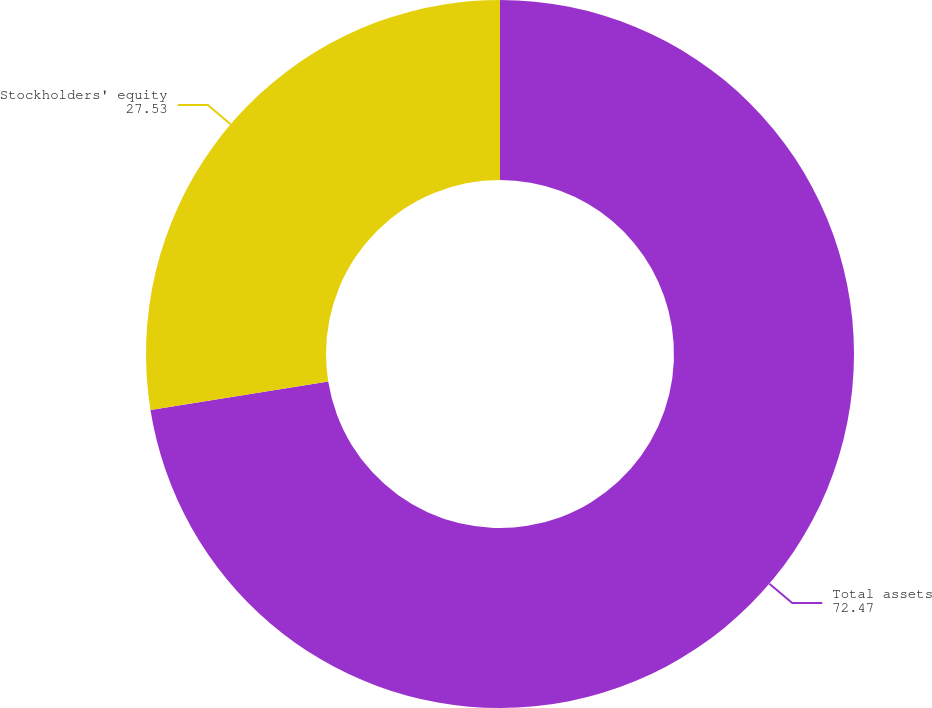<chart> <loc_0><loc_0><loc_500><loc_500><pie_chart><fcel>Total assets<fcel>Stockholders' equity<nl><fcel>72.47%<fcel>27.53%<nl></chart> 